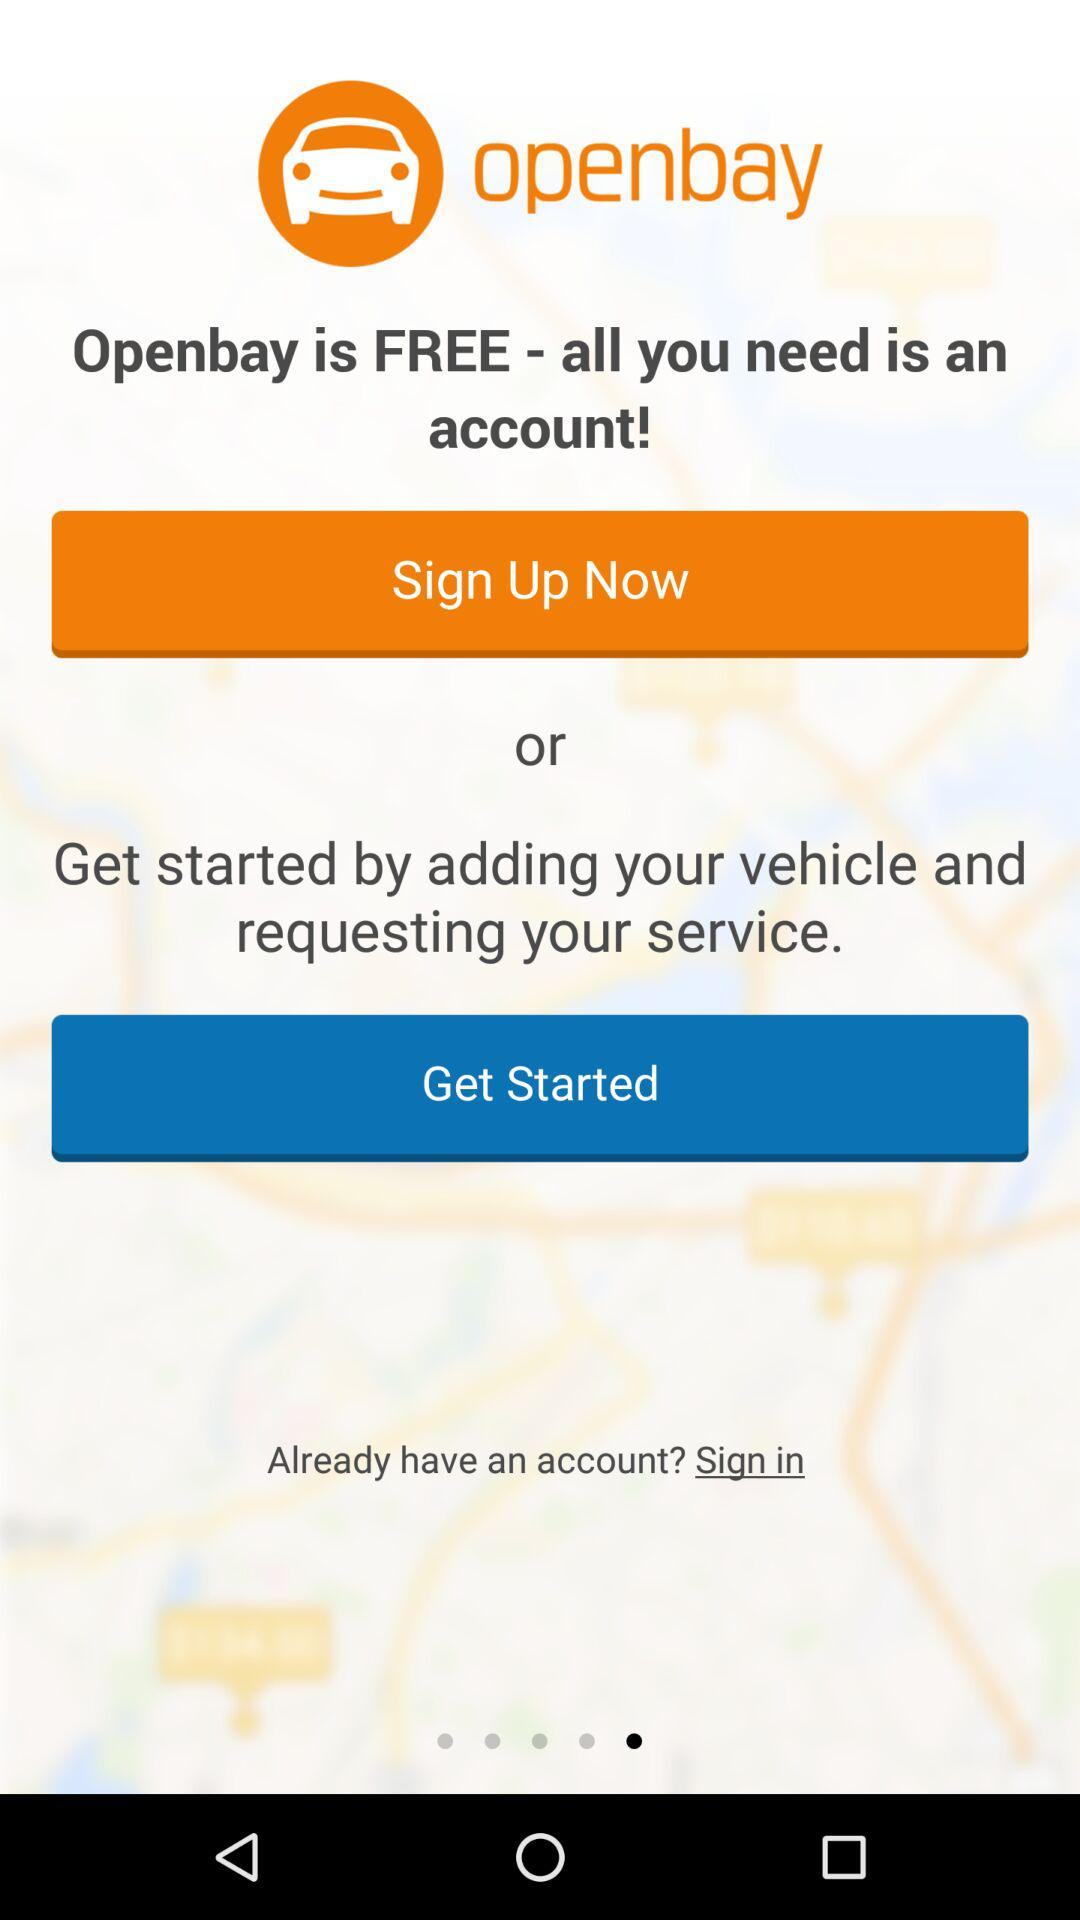How do you use it for free? For free, "all you need is an account". 